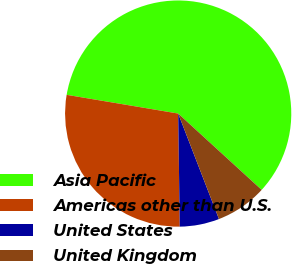Convert chart. <chart><loc_0><loc_0><loc_500><loc_500><pie_chart><fcel>Asia Pacific<fcel>Americas other than U.S.<fcel>United States<fcel>United Kingdom<nl><fcel>59.14%<fcel>27.87%<fcel>5.65%<fcel>7.34%<nl></chart> 